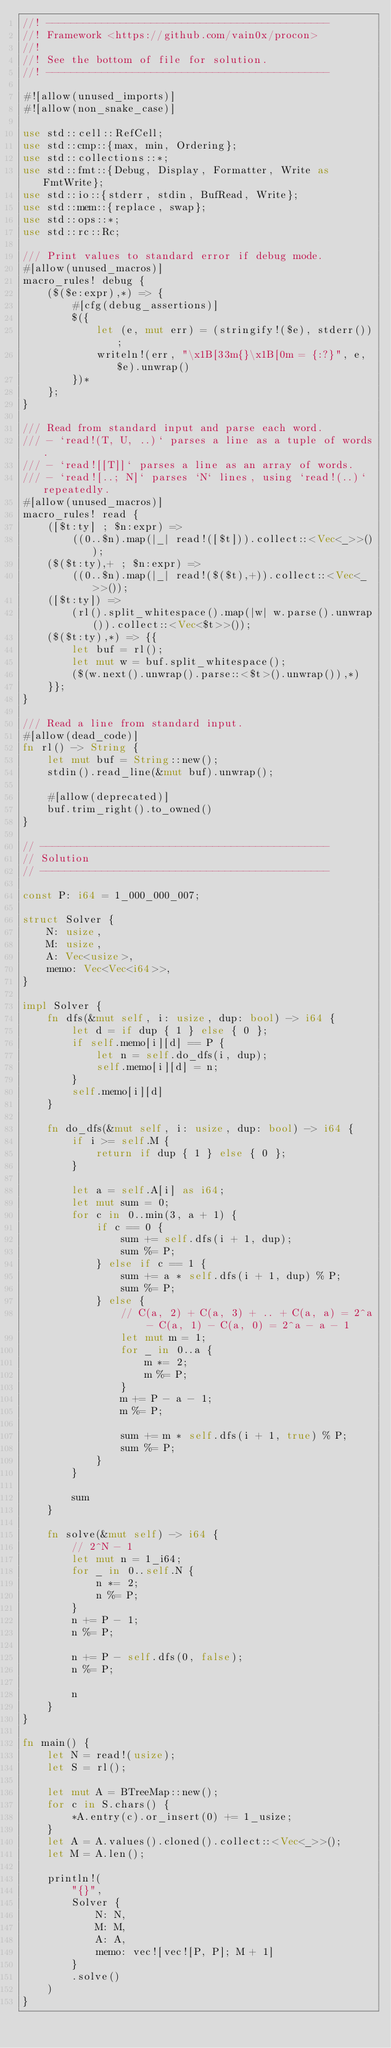<code> <loc_0><loc_0><loc_500><loc_500><_Rust_>//! ----------------------------------------------
//! Framework <https://github.com/vain0x/procon>
//!
//! See the bottom of file for solution.
//! ----------------------------------------------

#![allow(unused_imports)]
#![allow(non_snake_case)]

use std::cell::RefCell;
use std::cmp::{max, min, Ordering};
use std::collections::*;
use std::fmt::{Debug, Display, Formatter, Write as FmtWrite};
use std::io::{stderr, stdin, BufRead, Write};
use std::mem::{replace, swap};
use std::ops::*;
use std::rc::Rc;

/// Print values to standard error if debug mode.
#[allow(unused_macros)]
macro_rules! debug {
    ($($e:expr),*) => {
        #[cfg(debug_assertions)]
        $({
            let (e, mut err) = (stringify!($e), stderr());
            writeln!(err, "\x1B[33m{}\x1B[0m = {:?}", e, $e).unwrap()
        })*
    };
}

/// Read from standard input and parse each word.
/// - `read!(T, U, ..)` parses a line as a tuple of words.
/// - `read![[T]]` parses a line as an array of words.
/// - `read![..; N]` parses `N` lines, using `read!(..)` repeatedly.
#[allow(unused_macros)]
macro_rules! read {
    ([$t:ty] ; $n:expr) =>
        ((0..$n).map(|_| read!([$t])).collect::<Vec<_>>());
    ($($t:ty),+ ; $n:expr) =>
        ((0..$n).map(|_| read!($($t),+)).collect::<Vec<_>>());
    ([$t:ty]) =>
        (rl().split_whitespace().map(|w| w.parse().unwrap()).collect::<Vec<$t>>());
    ($($t:ty),*) => {{
        let buf = rl();
        let mut w = buf.split_whitespace();
        ($(w.next().unwrap().parse::<$t>().unwrap()),*)
    }};
}

/// Read a line from standard input.
#[allow(dead_code)]
fn rl() -> String {
    let mut buf = String::new();
    stdin().read_line(&mut buf).unwrap();

    #[allow(deprecated)]
    buf.trim_right().to_owned()
}

// -----------------------------------------------
// Solution
// -----------------------------------------------

const P: i64 = 1_000_000_007;

struct Solver {
    N: usize,
    M: usize,
    A: Vec<usize>,
    memo: Vec<Vec<i64>>,
}

impl Solver {
    fn dfs(&mut self, i: usize, dup: bool) -> i64 {
        let d = if dup { 1 } else { 0 };
        if self.memo[i][d] == P {
            let n = self.do_dfs(i, dup);
            self.memo[i][d] = n;
        }
        self.memo[i][d]
    }

    fn do_dfs(&mut self, i: usize, dup: bool) -> i64 {
        if i >= self.M {
            return if dup { 1 } else { 0 };
        }

        let a = self.A[i] as i64;
        let mut sum = 0;
        for c in 0..min(3, a + 1) {
            if c == 0 {
                sum += self.dfs(i + 1, dup);
                sum %= P;
            } else if c == 1 {
                sum += a * self.dfs(i + 1, dup) % P;
                sum %= P;
            } else {
                // C(a, 2) + C(a, 3) + .. + C(a, a) = 2^a - C(a, 1) - C(a, 0) = 2^a - a - 1
                let mut m = 1;
                for _ in 0..a {
                    m *= 2;
                    m %= P;
                }
                m += P - a - 1;
                m %= P;

                sum += m * self.dfs(i + 1, true) % P;
                sum %= P;
            }
        }

        sum
    }

    fn solve(&mut self) -> i64 {
        // 2^N - 1
        let mut n = 1_i64;
        for _ in 0..self.N {
            n *= 2;
            n %= P;
        }
        n += P - 1;
        n %= P;

        n += P - self.dfs(0, false);
        n %= P;

        n
    }
}

fn main() {
    let N = read!(usize);
    let S = rl();

    let mut A = BTreeMap::new();
    for c in S.chars() {
        *A.entry(c).or_insert(0) += 1_usize;
    }
    let A = A.values().cloned().collect::<Vec<_>>();
    let M = A.len();

    println!(
        "{}",
        Solver {
            N: N,
            M: M,
            A: A,
            memo: vec![vec![P, P]; M + 1]
        }
        .solve()
    )
}
</code> 